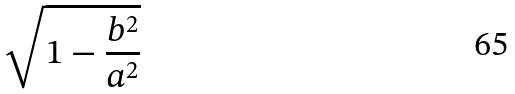Convert formula to latex. <formula><loc_0><loc_0><loc_500><loc_500>\sqrt { 1 - \frac { b ^ { 2 } } { a ^ { 2 } } }</formula> 